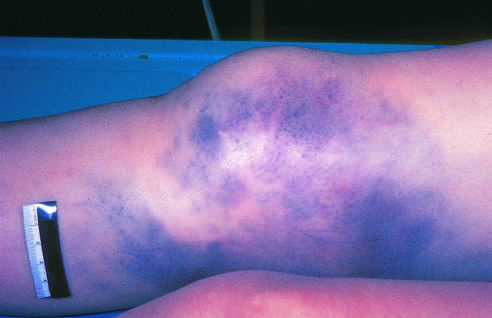has hemorrhage of subcutaneous vessels produced extensive discoloration?
Answer the question using a single word or phrase. Yes 